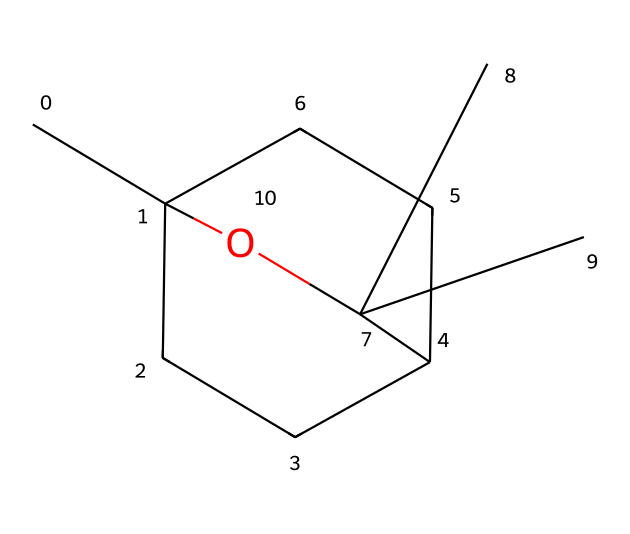What is the molecular formula of eucalyptol? To determine the molecular formula, we analyze the structure represented by the SMILES notation, counting the different atoms present. The carbon (C), hydrogen (H), and oxygen (O) atoms can be counted to derive the molecular formula.
Answer: C10H18O How many carbon atoms are present in eucalyptol? From the SMILES representation, we can identify and count the carbon atoms (C). In this structure, there are 10 carbon atoms present.
Answer: 10 What type of chemical compound is eucalyptol classified as? Eucalyptol is classified as a terpene, which is evident from its cyclic structure and natural occurrence in essential oils.
Answer: terpene What functional group is present in eucalyptol? By examining the structure, we see the presence of a hydroxyl (-OH) group, which indicates that eucalyptol has alcohol characteristics.
Answer: alcohol What is the total number of oxygen atoms in eucalyptol? Observing the structure in the SMILES notation shows that there is only one oxygen atom present, thus counting them gives the total.
Answer: 1 What effect does eucalyptol have on stress relief? Eucalyptol is known for its calming and refreshing properties, contributing to the stress-relieving effects found in certain essential oils used by media professionals.
Answer: calming Is eucalyptol a natural or synthetic compound? Eucalyptol is primarily obtained from natural sources like eucalyptus oil, indicating that it is a natural compound.
Answer: natural 